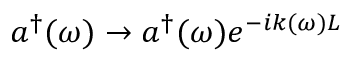Convert formula to latex. <formula><loc_0><loc_0><loc_500><loc_500>a ^ { \dag } ( \omega ) \rightarrow a ^ { \dag } ( \omega ) e ^ { - i k ( \omega ) L }</formula> 